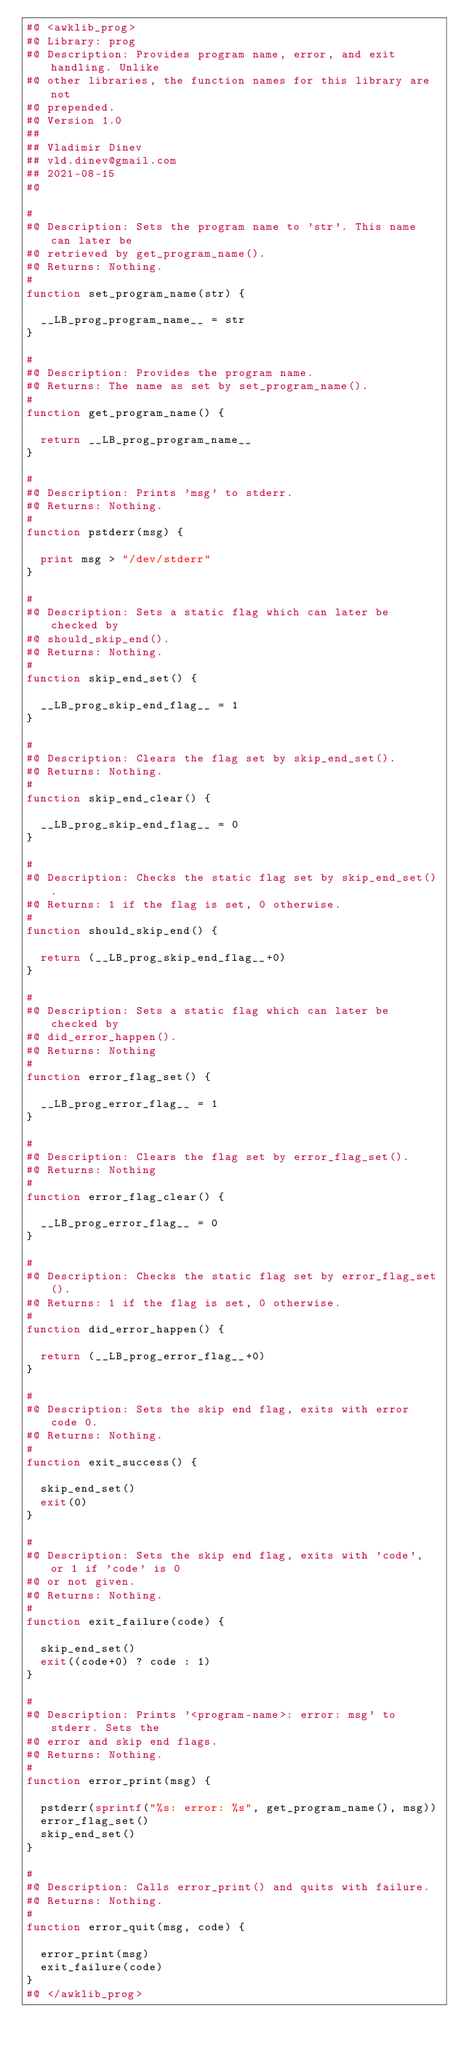Convert code to text. <code><loc_0><loc_0><loc_500><loc_500><_Awk_>#@ <awklib_prog>
#@ Library: prog
#@ Description: Provides program name, error, and exit handling. Unlike
#@ other libraries, the function names for this library are not
#@ prepended.
#@ Version 1.0
##
## Vladimir Dinev
## vld.dinev@gmail.com
## 2021-08-15
#@

#
#@ Description: Sets the program name to 'str'. This name can later be
#@ retrieved by get_program_name().
#@ Returns: Nothing.
#
function set_program_name(str) {

	__LB_prog_program_name__ = str
}

#
#@ Description: Provides the program name.
#@ Returns: The name as set by set_program_name().
#
function get_program_name() {

	return __LB_prog_program_name__
}

#
#@ Description: Prints 'msg' to stderr.
#@ Returns: Nothing.
#
function pstderr(msg) {

	print msg > "/dev/stderr"
}

#
#@ Description: Sets a static flag which can later be checked by
#@ should_skip_end().
#@ Returns: Nothing.
#
function skip_end_set() {

	__LB_prog_skip_end_flag__ = 1
}

#
#@ Description: Clears the flag set by skip_end_set().
#@ Returns: Nothing.
#
function skip_end_clear() {

	__LB_prog_skip_end_flag__ = 0
}

#
#@ Description: Checks the static flag set by skip_end_set().
#@ Returns: 1 if the flag is set, 0 otherwise.
#
function should_skip_end() {

	return (__LB_prog_skip_end_flag__+0)
}

#
#@ Description: Sets a static flag which can later be checked by
#@ did_error_happen().
#@ Returns: Nothing
#
function error_flag_set() {

	__LB_prog_error_flag__ = 1
}

#
#@ Description: Clears the flag set by error_flag_set().
#@ Returns: Nothing
#
function error_flag_clear() {

	__LB_prog_error_flag__ = 0
}

#
#@ Description: Checks the static flag set by error_flag_set().
#@ Returns: 1 if the flag is set, 0 otherwise.
#
function did_error_happen() {

	return (__LB_prog_error_flag__+0)
}

#
#@ Description: Sets the skip end flag, exits with error code 0.
#@ Returns: Nothing.
#
function exit_success() {
	
	skip_end_set()
	exit(0)
}

#
#@ Description: Sets the skip end flag, exits with 'code', or 1 if 'code' is 0
#@ or not given.
#@ Returns: Nothing.
#
function exit_failure(code) {

	skip_end_set()
	exit((code+0) ? code : 1)
}

#
#@ Description: Prints '<program-name>: error: msg' to stderr. Sets the
#@ error and skip end flags.
#@ Returns: Nothing.
#
function error_print(msg) {

	pstderr(sprintf("%s: error: %s", get_program_name(), msg))
	error_flag_set()
	skip_end_set()
}

#
#@ Description: Calls error_print() and quits with failure.
#@ Returns: Nothing.
#
function error_quit(msg, code) {

	error_print(msg)
	exit_failure(code)
}
#@ </awklib_prog>
</code> 